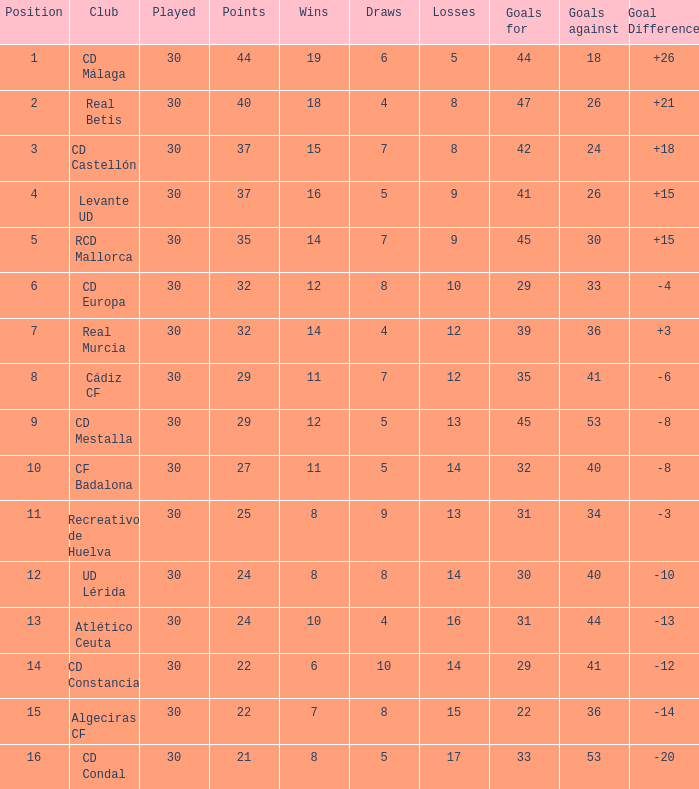What is the number of losses when the goal difference was -8, and position is smaller than 10? 1.0. 